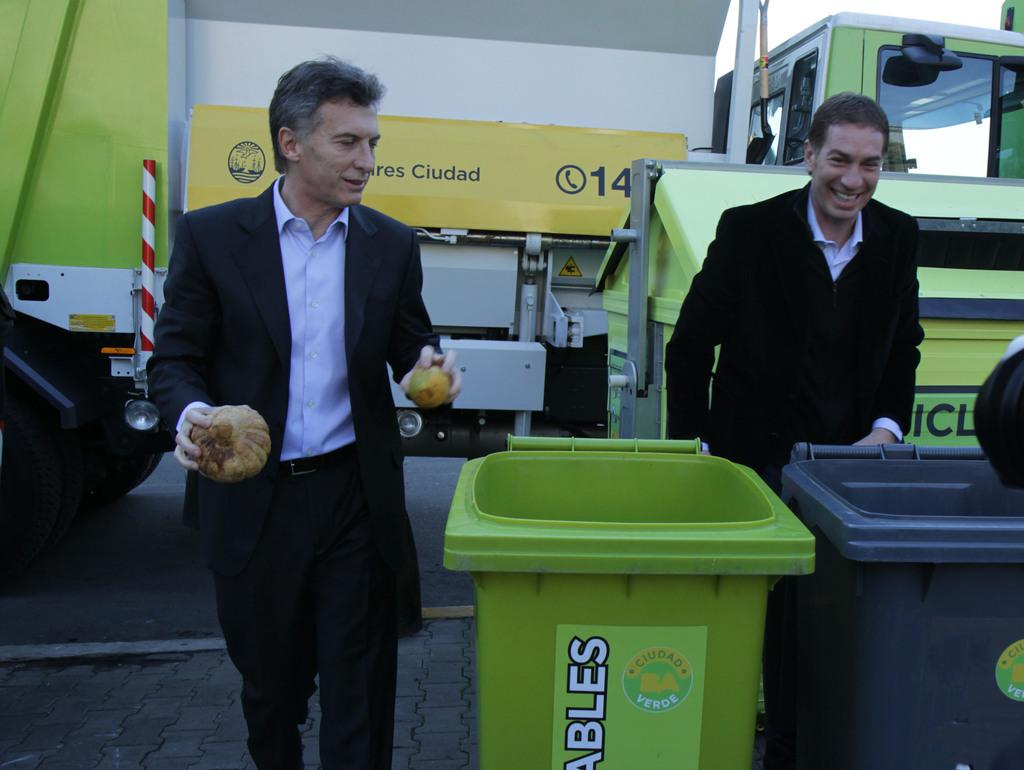<image>
Provide a brief description of the given image. Two man stand in front of a yellow awning which reads, in part, "Ciudad." 